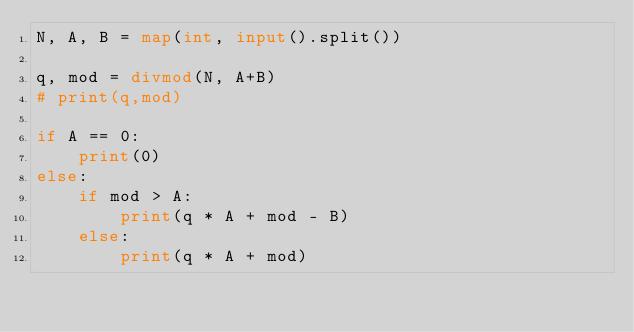Convert code to text. <code><loc_0><loc_0><loc_500><loc_500><_Python_>N, A, B = map(int, input().split())

q, mod = divmod(N, A+B)
# print(q,mod)

if A == 0:
    print(0)
else:
    if mod > A:
        print(q * A + mod - B)
    else:
        print(q * A + mod)</code> 